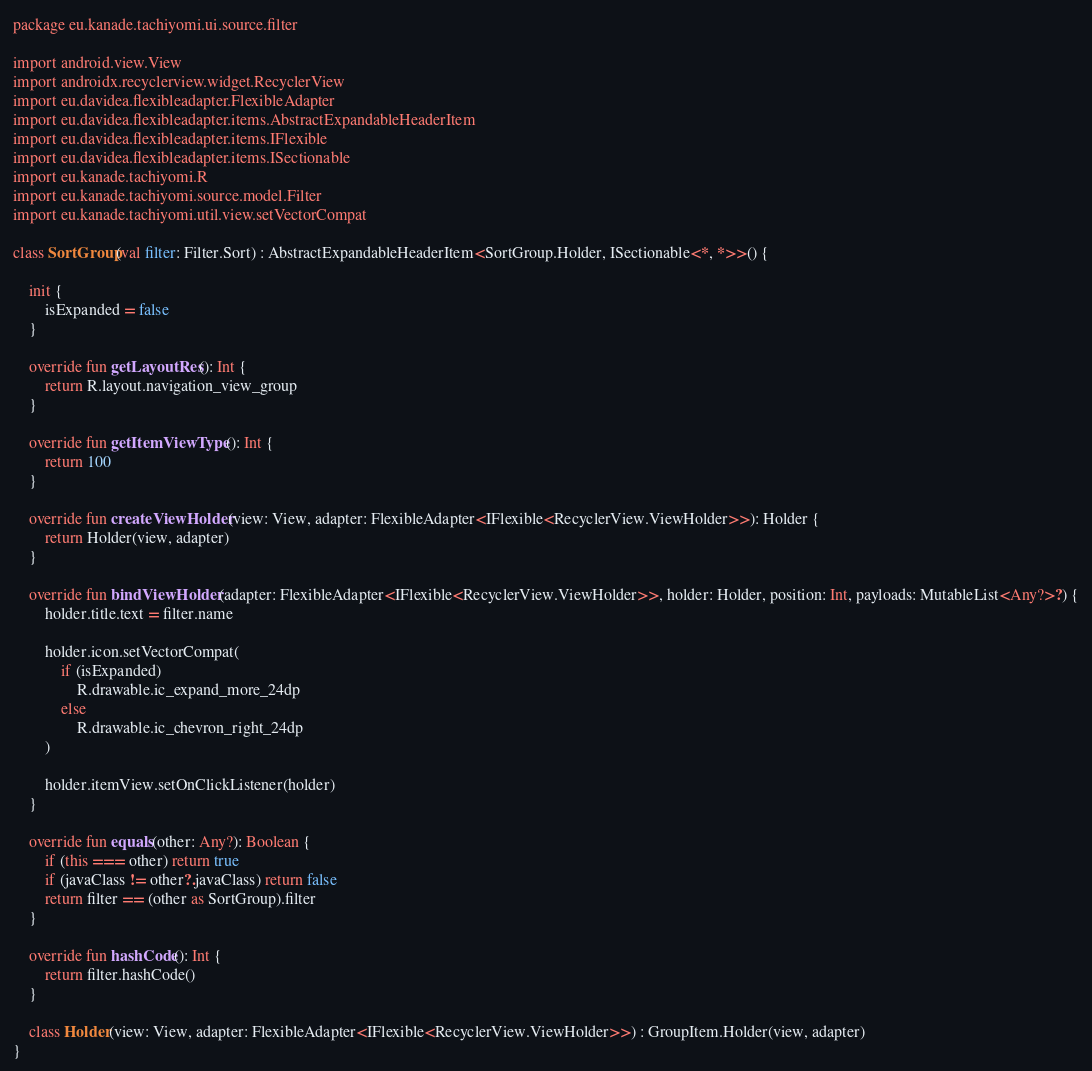<code> <loc_0><loc_0><loc_500><loc_500><_Kotlin_>package eu.kanade.tachiyomi.ui.source.filter

import android.view.View
import androidx.recyclerview.widget.RecyclerView
import eu.davidea.flexibleadapter.FlexibleAdapter
import eu.davidea.flexibleadapter.items.AbstractExpandableHeaderItem
import eu.davidea.flexibleadapter.items.IFlexible
import eu.davidea.flexibleadapter.items.ISectionable
import eu.kanade.tachiyomi.R
import eu.kanade.tachiyomi.source.model.Filter
import eu.kanade.tachiyomi.util.view.setVectorCompat

class SortGroup(val filter: Filter.Sort) : AbstractExpandableHeaderItem<SortGroup.Holder, ISectionable<*, *>>() {

    init {
        isExpanded = false
    }

    override fun getLayoutRes(): Int {
        return R.layout.navigation_view_group
    }

    override fun getItemViewType(): Int {
        return 100
    }

    override fun createViewHolder(view: View, adapter: FlexibleAdapter<IFlexible<RecyclerView.ViewHolder>>): Holder {
        return Holder(view, adapter)
    }

    override fun bindViewHolder(adapter: FlexibleAdapter<IFlexible<RecyclerView.ViewHolder>>, holder: Holder, position: Int, payloads: MutableList<Any?>?) {
        holder.title.text = filter.name

        holder.icon.setVectorCompat(
            if (isExpanded)
                R.drawable.ic_expand_more_24dp
            else
                R.drawable.ic_chevron_right_24dp
        )

        holder.itemView.setOnClickListener(holder)
    }

    override fun equals(other: Any?): Boolean {
        if (this === other) return true
        if (javaClass != other?.javaClass) return false
        return filter == (other as SortGroup).filter
    }

    override fun hashCode(): Int {
        return filter.hashCode()
    }

    class Holder(view: View, adapter: FlexibleAdapter<IFlexible<RecyclerView.ViewHolder>>) : GroupItem.Holder(view, adapter)
}
</code> 